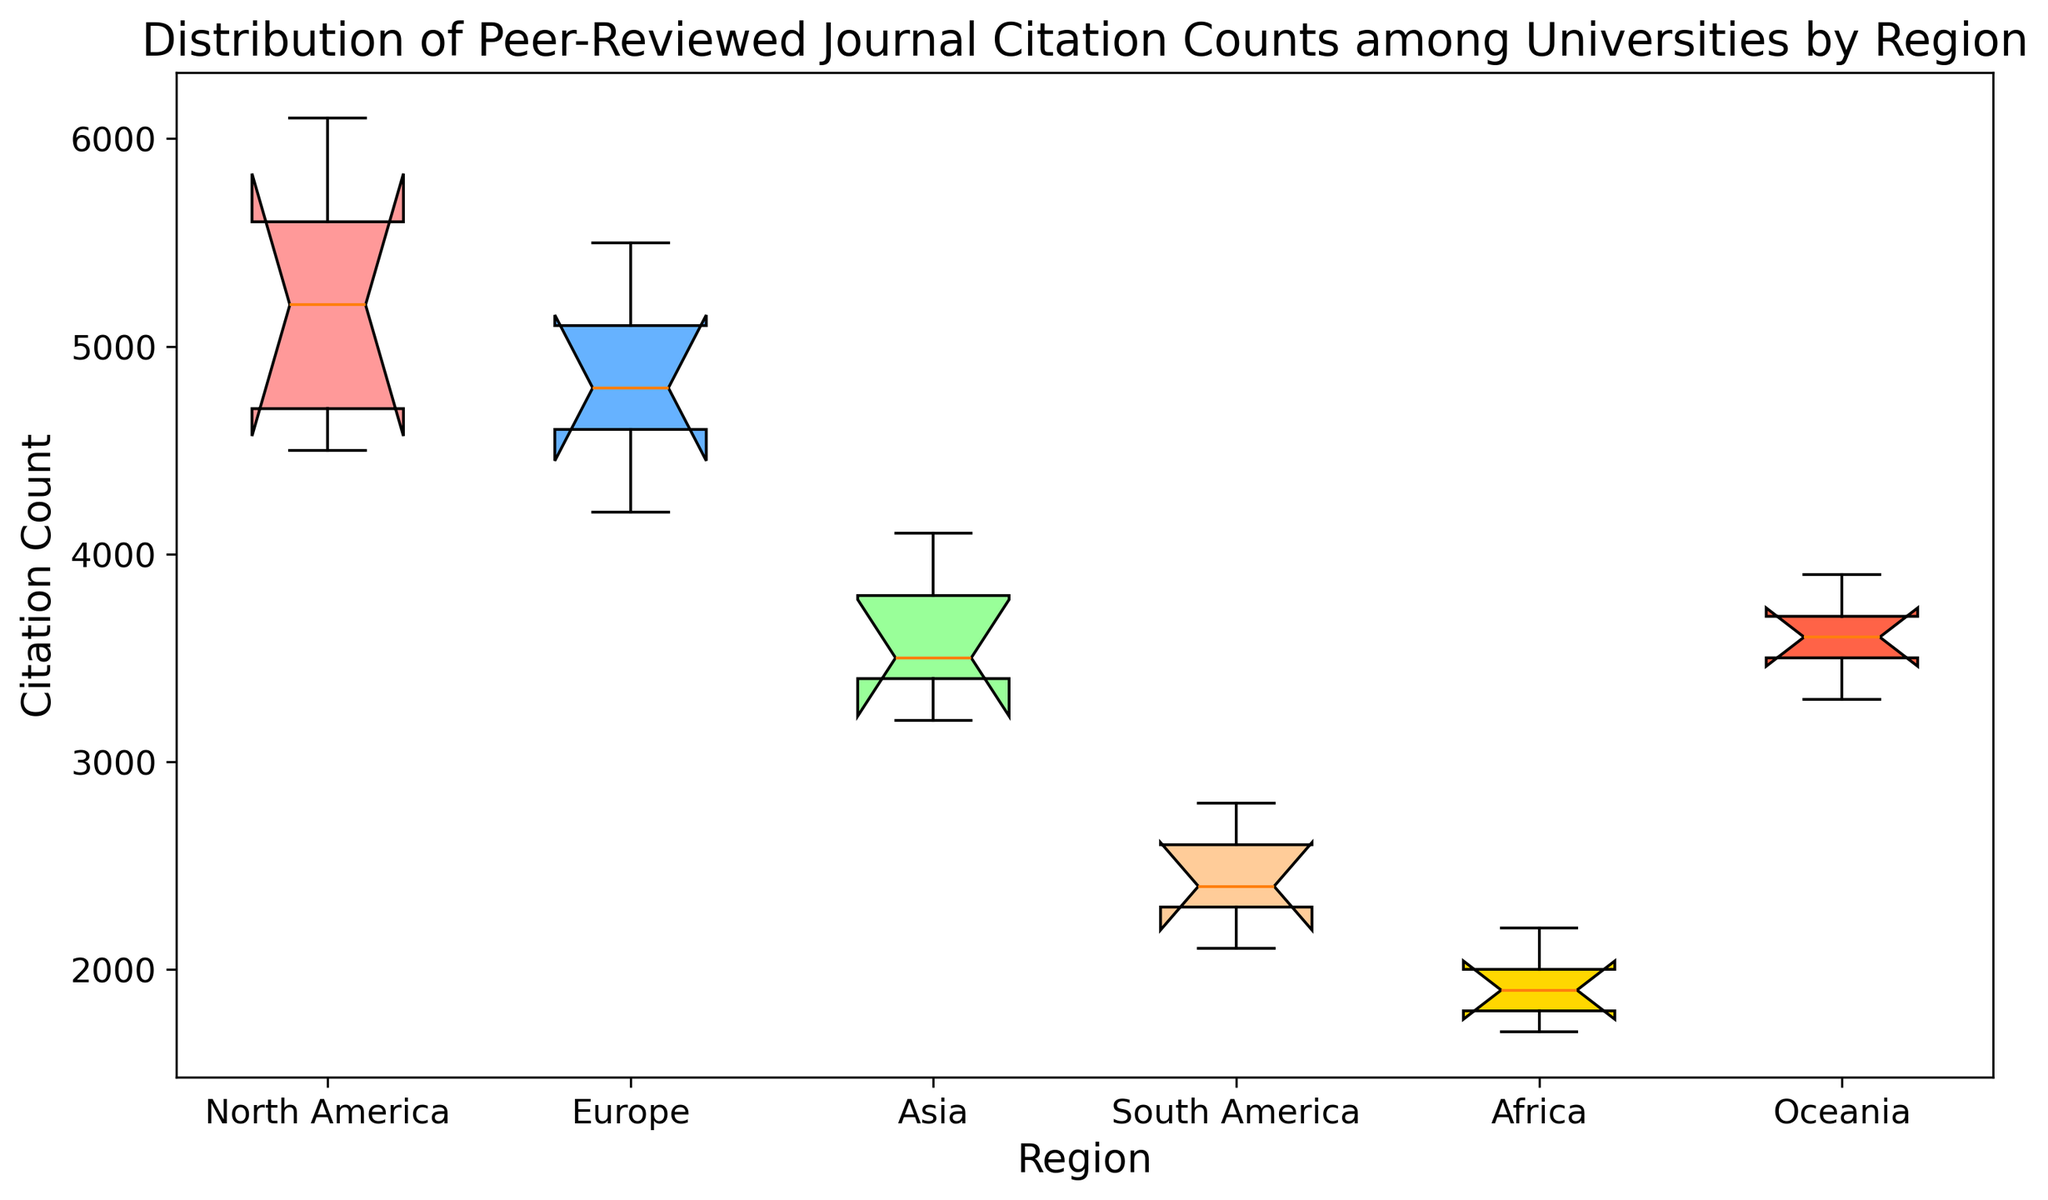Which region has the highest median citation count? The figure shows the median line inside each box plot. The region with the highest median line is identifiable visually.
Answer: North America What's the interquartile range (IQR) for Asia's citation counts? The interquartile range is calculated as the difference between the third quartile (Q3) and the first quartile (Q1). Based on the box plot, find Q3 at the top of the box and Q1 at the bottom of the box for Asia and subtract Q1 from Q3.
Answer: 700 Which region shows the largest variability in citation counts? Variability can be assessed by looking at the spread of the box and the whiskers. The region with the widest box and whiskers indicates the largest variability.
Answer: North America Compare the median citation counts of Europe and Oceania. Which one is higher? The median is the middle line inside the box in the box plot. Compare the position of the median lines for Europe and Oceania.
Answer: Europe By how much does the 75th percentile (Q3) of North America exceed that of Africa? Locate the Q3 (upper edge of the box) for both North America and Africa in the plot. Subtract Q3 of Africa from Q3 of North America.
Answer: 4000 Which region has the smallest range in citation counts? The range is determined by the difference between the maximum and minimum values (whiskers). Identify the region with the closest whiskers.
Answer: Africa How does the median citation count of South America compare to that of Asia? Examine the median lines within the boxes for South America and Asia. Compare their relative positions.
Answer: South America's median is lower than Asia's Identify the region with the smallest interquartile range (IQR) and describe its citation count spread. The smallest interquartile range can be found by looking for the narrowest box in the box plot. Identify the region and describe its box span.
Answer: Africa, 0-500 Which regions have outliers in their citation counts? Outliers are typically shown as points outside the whiskers in box plots. Identify any regions that have such points.
Answer: None What is the range of citation counts for Europe? The range is found by identifying the minimum and maximum whiskers for Europe and calculating the difference between them.
Answer: 1300 